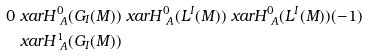Convert formula to latex. <formula><loc_0><loc_0><loc_500><loc_500>0 & \ x a r H ^ { 0 } _ { \ A } ( G _ { I } ( M ) ) \ x a r H ^ { 0 } _ { \ A } ( L ^ { I } ( M ) ) \ x a r H ^ { 0 } _ { \ A } ( L ^ { I } ( M ) ) ( - 1 ) \\ & \ x a r H ^ { 1 } _ { \ A } ( G _ { I } ( M ) )</formula> 